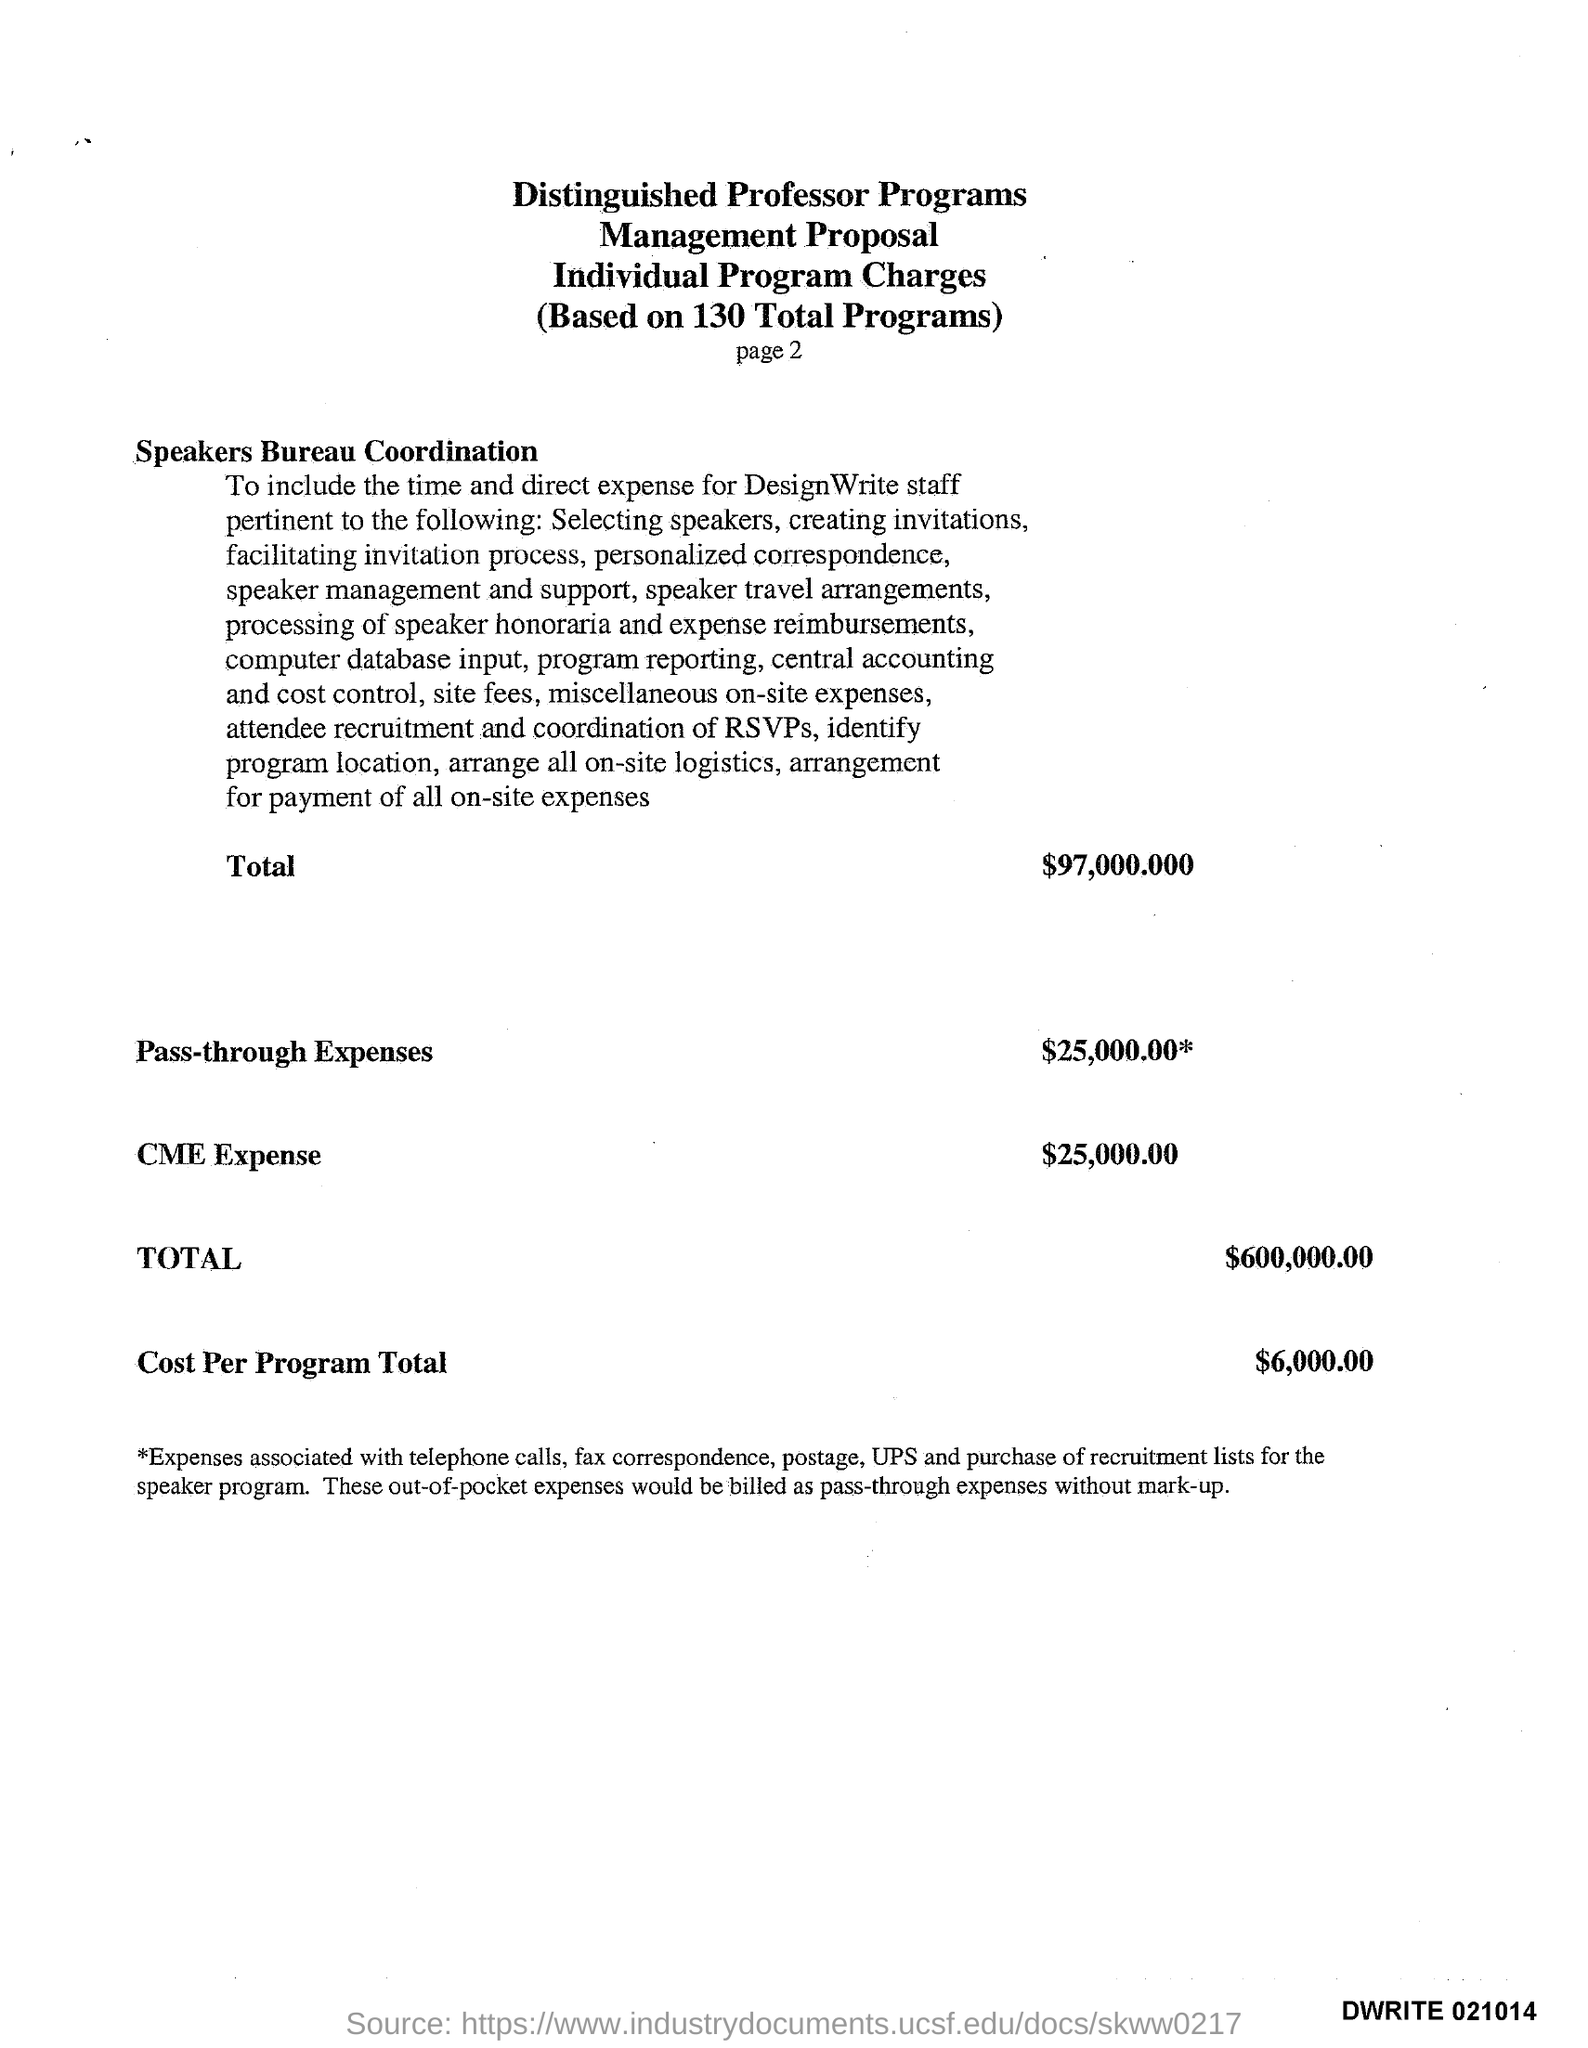What is the pass- through expenses?
Provide a short and direct response. $25,000.00. What is the CME Expense?
Keep it short and to the point. $25,000.00. What is the cost per program total?
Your response must be concise. $6,000.00. 